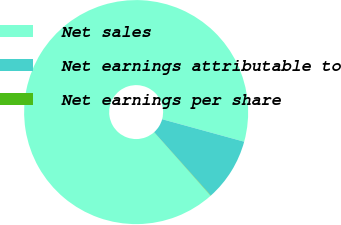Convert chart. <chart><loc_0><loc_0><loc_500><loc_500><pie_chart><fcel>Net sales<fcel>Net earnings attributable to<fcel>Net earnings per share<nl><fcel>90.83%<fcel>9.12%<fcel>0.04%<nl></chart> 